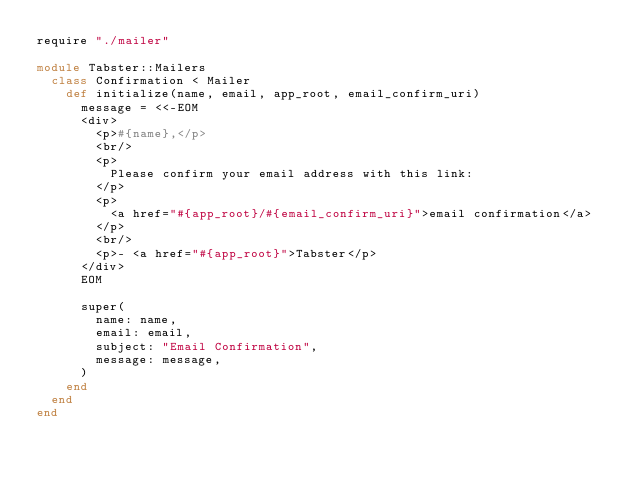<code> <loc_0><loc_0><loc_500><loc_500><_Crystal_>require "./mailer"

module Tabster::Mailers
  class Confirmation < Mailer
    def initialize(name, email, app_root, email_confirm_uri)
      message = <<-EOM
      <div>
        <p>#{name},</p>
        <br/>
        <p>
          Please confirm your email address with this link:
        </p>
        <p>
          <a href="#{app_root}/#{email_confirm_uri}">email confirmation</a>
        </p>
        <br/>
        <p>- <a href="#{app_root}">Tabster</p>
      </div>
      EOM

      super(
        name: name,
        email: email,
        subject: "Email Confirmation",
        message: message,
      )
    end
  end
end
</code> 